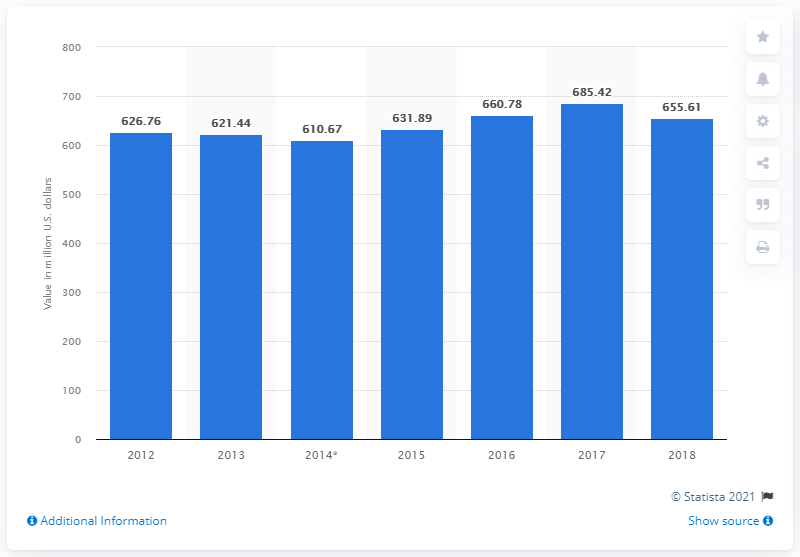How many dollars worth of cocoa was exported from Mexico in 2018? In 2018, Mexico exported cocoa valued at approximately 655.61 million U.S. dollars, indicating a robust trade in this commodity. 